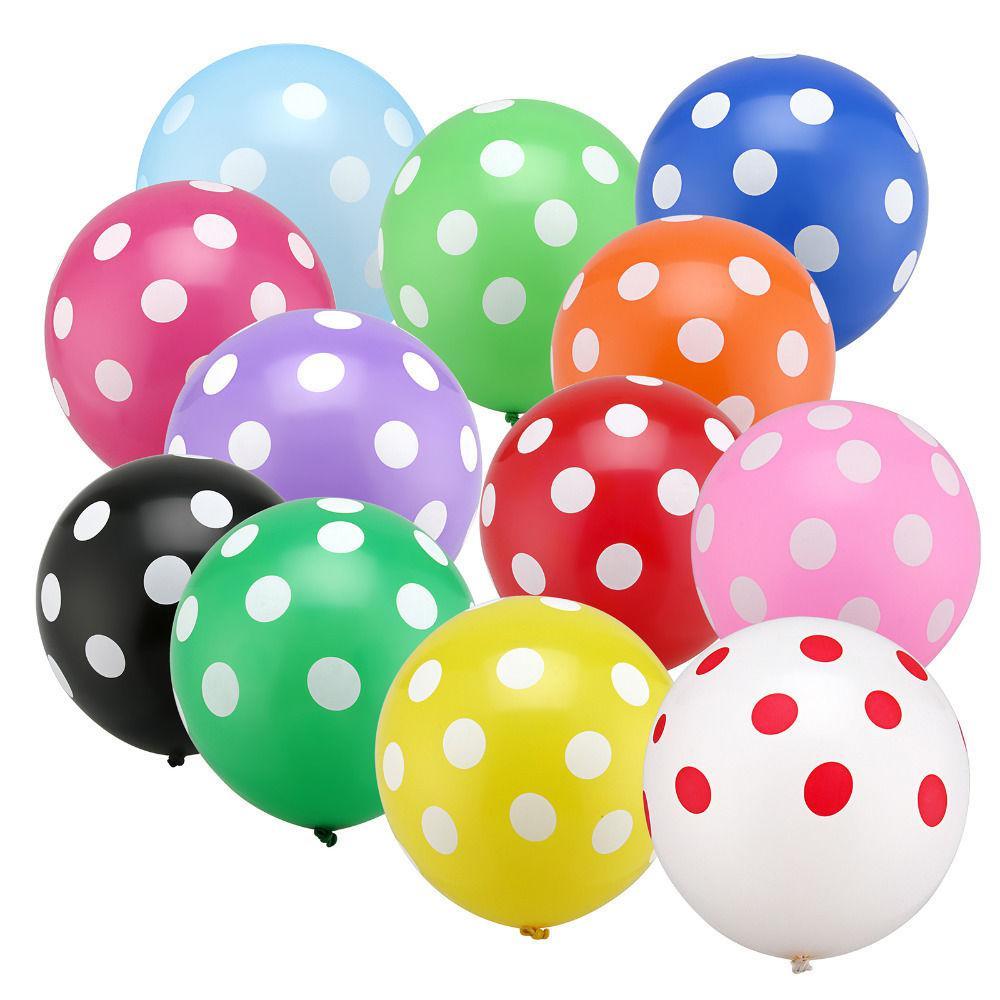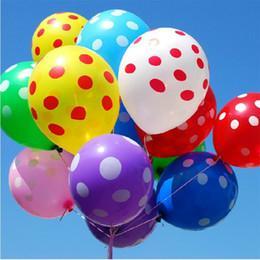The first image is the image on the left, the second image is the image on the right. For the images shown, is this caption "In one of the images there is a stuffed bear next to multiple solid colored balloons." true? Answer yes or no. No. 